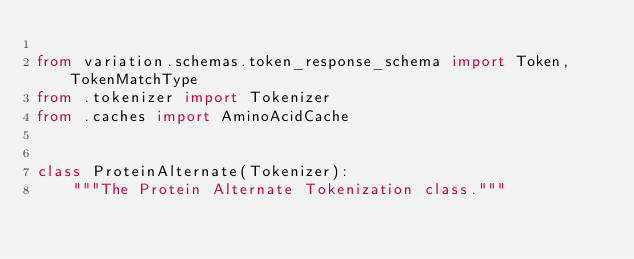<code> <loc_0><loc_0><loc_500><loc_500><_Python_>
from variation.schemas.token_response_schema import Token, TokenMatchType
from .tokenizer import Tokenizer
from .caches import AminoAcidCache


class ProteinAlternate(Tokenizer):
    """The Protein Alternate Tokenization class."""
</code> 